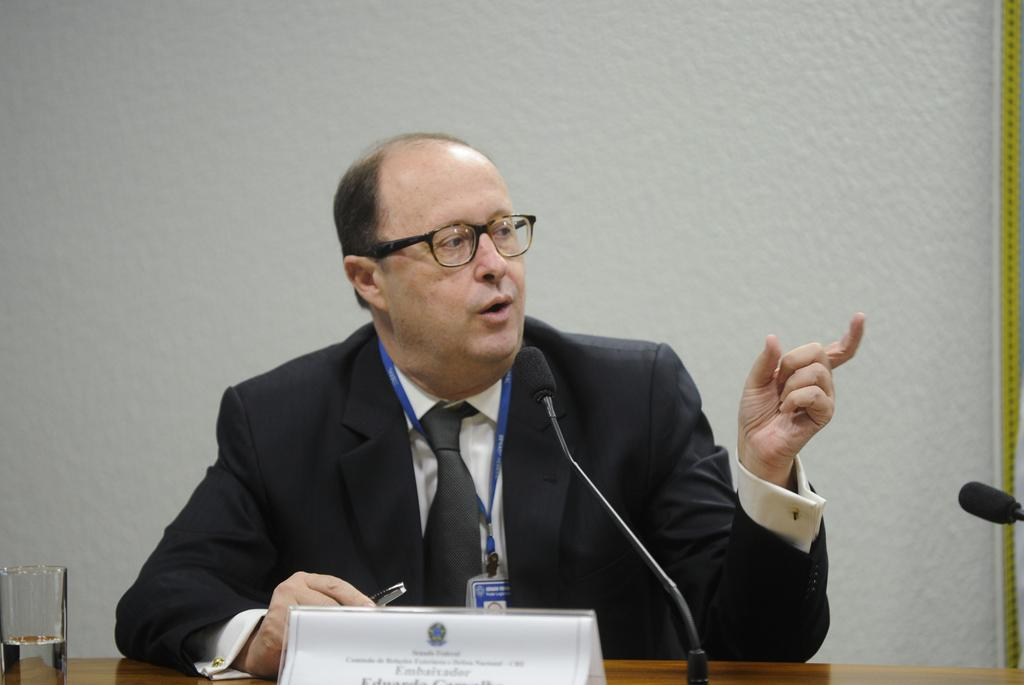What is the person in the image doing? There is a person sitting in the image, and they are holding an object that looks like a pen. What can be seen near the person in the image? There are mice in the image, as well as a glass with water. What is on the table in the image? There is a name board on the table. What is visible in the background of the image? There is a wall in the background of the image. What type of tax can be seen being paid in the image? There is no indication of any tax being paid in the image; it features a person sitting with a pen, mice, a glass with water, a name board, and a wall in the background. 